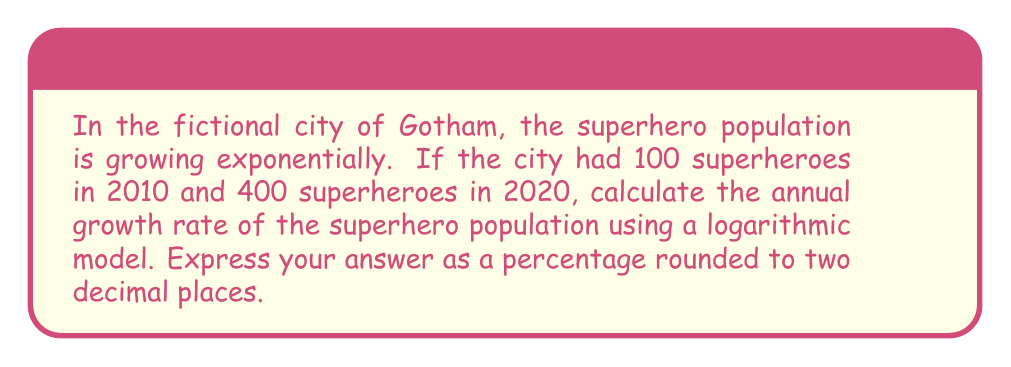Provide a solution to this math problem. Let's approach this step-by-step using the exponential growth formula and logarithms:

1) The exponential growth formula is:
   $A = P(1 + r)^t$
   Where A is the final amount, P is the initial amount, r is the growth rate, and t is the time period.

2) We know:
   P = 100 (initial population in 2010)
   A = 400 (final population in 2020)
   t = 10 years

3) Let's substitute these values into the formula:
   $400 = 100(1 + r)^{10}$

4) Divide both sides by 100:
   $4 = (1 + r)^{10}$

5) Take the natural logarithm of both sides:
   $\ln(4) = \ln((1 + r)^{10})$

6) Use the logarithm property $\ln(x^n) = n\ln(x)$:
   $\ln(4) = 10\ln(1 + r)$

7) Divide both sides by 10:
   $\frac{\ln(4)}{10} = \ln(1 + r)$

8) Take $e$ to the power of both sides:
   $e^{\frac{\ln(4)}{10}} = e^{\ln(1 + r)} = 1 + r$

9) Subtract 1 from both sides:
   $e^{\frac{\ln(4)}{10}} - 1 = r$

10) Calculate:
    $r = e^{\frac{\ln(4)}{10}} - 1 \approx 0.1486$

11) Convert to percentage:
    $0.1486 \times 100\% = 14.86\%$

Rounding to two decimal places: 14.86%
Answer: 14.86% 